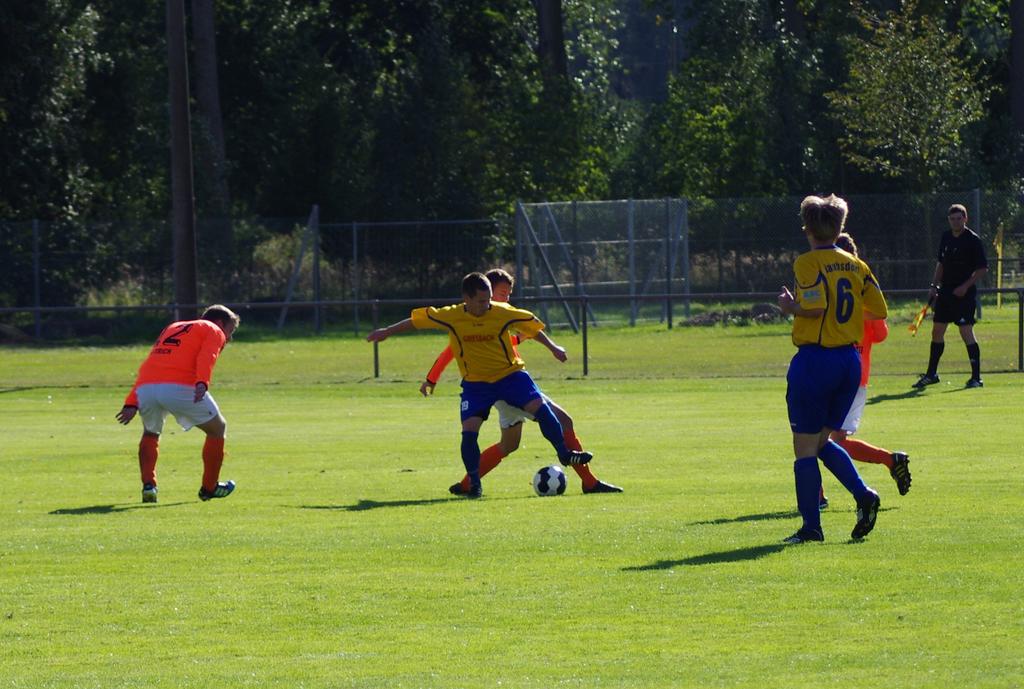What number is the player on the right?
Ensure brevity in your answer.  6. Which number is on the orange jersey to the left?
Your answer should be very brief. 2. 